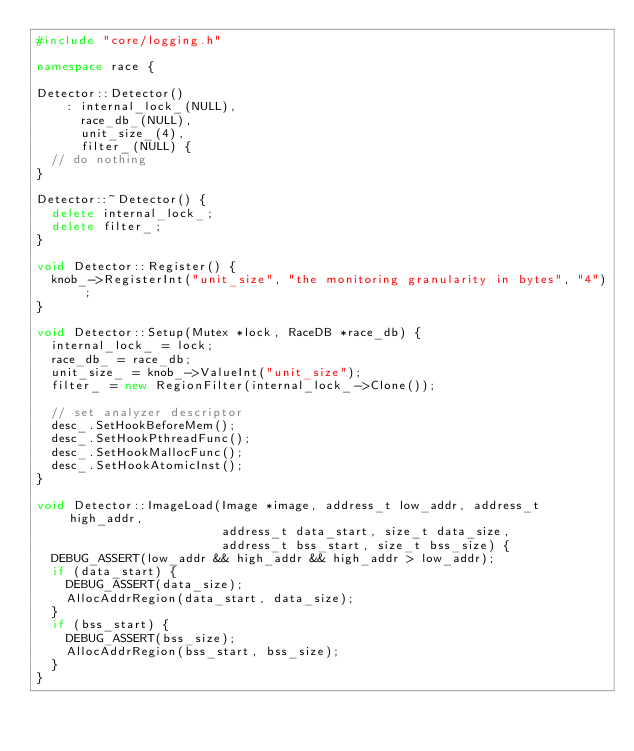Convert code to text. <code><loc_0><loc_0><loc_500><loc_500><_C++_>#include "core/logging.h"

namespace race {

Detector::Detector()
    : internal_lock_(NULL),
      race_db_(NULL),
      unit_size_(4),
      filter_(NULL) {
  // do nothing
}

Detector::~Detector() {
  delete internal_lock_;
  delete filter_;
}

void Detector::Register() {
  knob_->RegisterInt("unit_size", "the monitoring granularity in bytes", "4");
}

void Detector::Setup(Mutex *lock, RaceDB *race_db) {
  internal_lock_ = lock;
  race_db_ = race_db;
  unit_size_ = knob_->ValueInt("unit_size");
  filter_ = new RegionFilter(internal_lock_->Clone());

  // set analyzer descriptor
  desc_.SetHookBeforeMem();
  desc_.SetHookPthreadFunc();
  desc_.SetHookMallocFunc();
  desc_.SetHookAtomicInst();
}

void Detector::ImageLoad(Image *image, address_t low_addr, address_t high_addr,
                         address_t data_start, size_t data_size,
                         address_t bss_start, size_t bss_size) {
  DEBUG_ASSERT(low_addr && high_addr && high_addr > low_addr);
  if (data_start) {
    DEBUG_ASSERT(data_size);
    AllocAddrRegion(data_start, data_size);
  }
  if (bss_start) {
    DEBUG_ASSERT(bss_size);
    AllocAddrRegion(bss_start, bss_size);
  }
}
</code> 